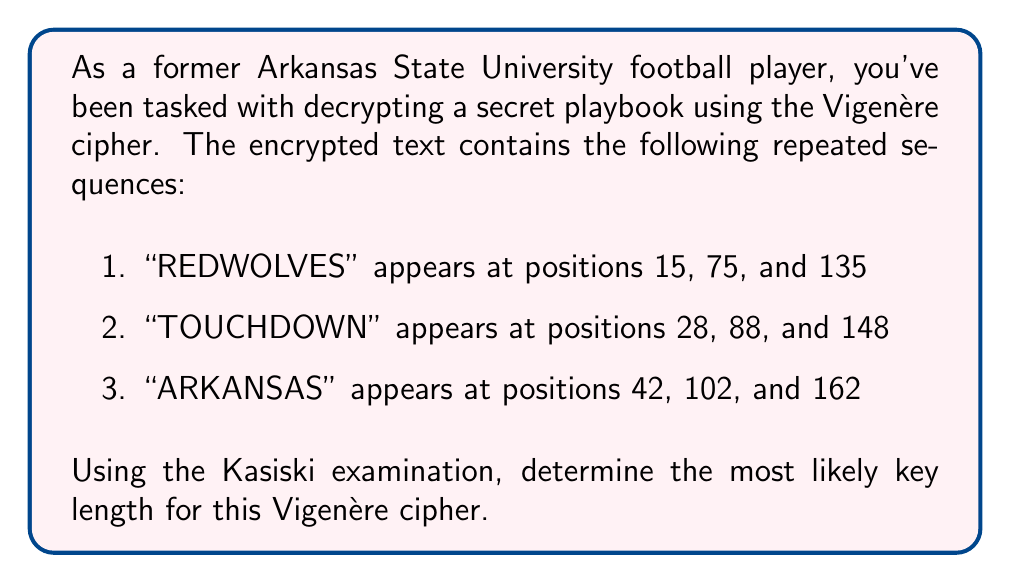Teach me how to tackle this problem. To determine the key length using the Kasiski examination, we follow these steps:

1. Identify the distances between repeated sequences:
   - "REDWOLVES": 75 - 15 = 60, 135 - 75 = 60
   - "TOUCHDOWN": 88 - 28 = 60, 148 - 88 = 60
   - "ARKANSAS": 102 - 42 = 60, 162 - 102 = 60

2. Calculate the greatest common divisor (GCD) of these distances:
   $GCD(60, 60, 60) = 60$

3. Factor the GCD:
   $60 = 2^2 \times 3 \times 5$

4. The most likely key length is the largest factor of the GCD that makes sense for a Vigenère cipher key. In this case, all factors are potential key lengths:
   Possible key lengths: 2, 3, 4, 5, 6, 10, 12, 15, 20, 30, 60

5. Choose the largest reasonable factor as the most likely key length. For a Vigenère cipher, a key length of 5 or 6 is common and practical.

Therefore, the most likely key length for this Vigenère cipher is 6.
Answer: 6 